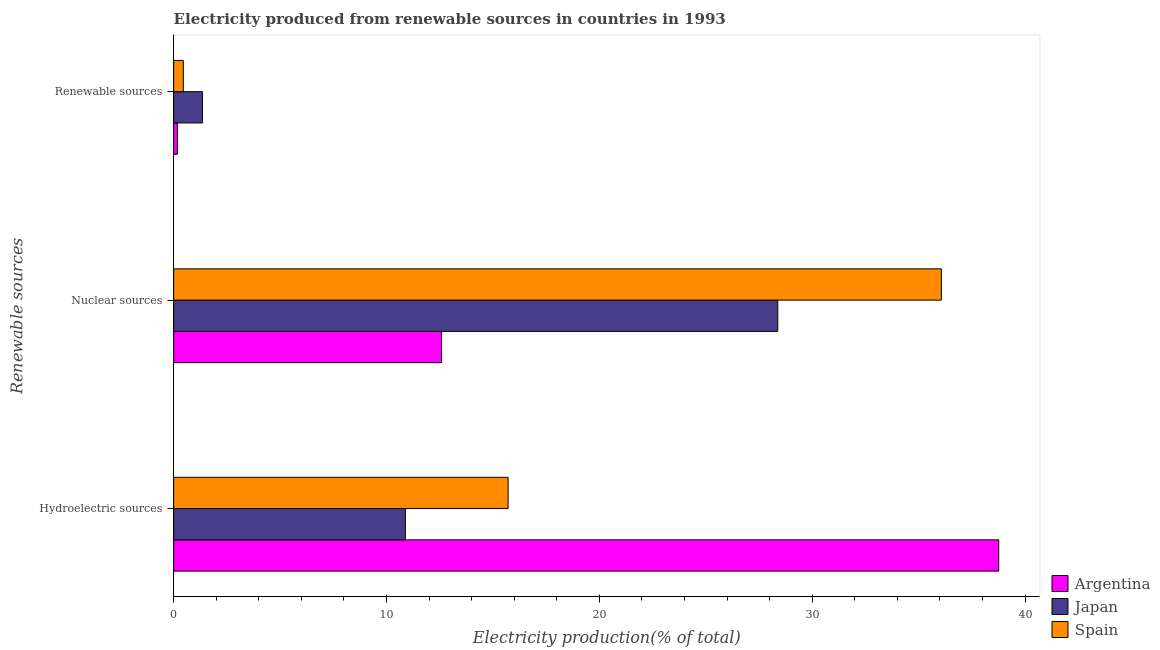How many different coloured bars are there?
Keep it short and to the point. 3. Are the number of bars per tick equal to the number of legend labels?
Offer a terse response. Yes. How many bars are there on the 3rd tick from the bottom?
Ensure brevity in your answer.  3. What is the label of the 3rd group of bars from the top?
Make the answer very short. Hydroelectric sources. What is the percentage of electricity produced by hydroelectric sources in Argentina?
Offer a terse response. 38.76. Across all countries, what is the maximum percentage of electricity produced by nuclear sources?
Your answer should be compact. 36.07. Across all countries, what is the minimum percentage of electricity produced by nuclear sources?
Keep it short and to the point. 12.59. In which country was the percentage of electricity produced by renewable sources minimum?
Provide a succinct answer. Argentina. What is the total percentage of electricity produced by nuclear sources in the graph?
Provide a succinct answer. 77.03. What is the difference between the percentage of electricity produced by hydroelectric sources in Japan and that in Argentina?
Provide a succinct answer. -27.88. What is the difference between the percentage of electricity produced by renewable sources in Argentina and the percentage of electricity produced by nuclear sources in Japan?
Make the answer very short. -28.21. What is the average percentage of electricity produced by hydroelectric sources per country?
Keep it short and to the point. 21.78. What is the difference between the percentage of electricity produced by renewable sources and percentage of electricity produced by hydroelectric sources in Spain?
Keep it short and to the point. -15.26. What is the ratio of the percentage of electricity produced by nuclear sources in Spain to that in Argentina?
Ensure brevity in your answer.  2.87. What is the difference between the highest and the second highest percentage of electricity produced by nuclear sources?
Keep it short and to the point. 7.69. What is the difference between the highest and the lowest percentage of electricity produced by hydroelectric sources?
Give a very brief answer. 27.88. Is the sum of the percentage of electricity produced by hydroelectric sources in Argentina and Spain greater than the maximum percentage of electricity produced by nuclear sources across all countries?
Keep it short and to the point. Yes. Is it the case that in every country, the sum of the percentage of electricity produced by hydroelectric sources and percentage of electricity produced by nuclear sources is greater than the percentage of electricity produced by renewable sources?
Offer a very short reply. Yes. Are the values on the major ticks of X-axis written in scientific E-notation?
Provide a succinct answer. No. What is the title of the graph?
Give a very brief answer. Electricity produced from renewable sources in countries in 1993. Does "Turkmenistan" appear as one of the legend labels in the graph?
Give a very brief answer. No. What is the label or title of the Y-axis?
Your answer should be compact. Renewable sources. What is the Electricity production(% of total) of Argentina in Hydroelectric sources?
Offer a very short reply. 38.76. What is the Electricity production(% of total) in Japan in Hydroelectric sources?
Your response must be concise. 10.88. What is the Electricity production(% of total) of Spain in Hydroelectric sources?
Ensure brevity in your answer.  15.71. What is the Electricity production(% of total) in Argentina in Nuclear sources?
Provide a succinct answer. 12.59. What is the Electricity production(% of total) in Japan in Nuclear sources?
Your answer should be very brief. 28.38. What is the Electricity production(% of total) in Spain in Nuclear sources?
Ensure brevity in your answer.  36.07. What is the Electricity production(% of total) of Argentina in Renewable sources?
Offer a terse response. 0.17. What is the Electricity production(% of total) of Japan in Renewable sources?
Keep it short and to the point. 1.35. What is the Electricity production(% of total) in Spain in Renewable sources?
Offer a terse response. 0.45. Across all Renewable sources, what is the maximum Electricity production(% of total) in Argentina?
Make the answer very short. 38.76. Across all Renewable sources, what is the maximum Electricity production(% of total) in Japan?
Keep it short and to the point. 28.38. Across all Renewable sources, what is the maximum Electricity production(% of total) of Spain?
Give a very brief answer. 36.07. Across all Renewable sources, what is the minimum Electricity production(% of total) of Argentina?
Give a very brief answer. 0.17. Across all Renewable sources, what is the minimum Electricity production(% of total) of Japan?
Offer a very short reply. 1.35. Across all Renewable sources, what is the minimum Electricity production(% of total) of Spain?
Offer a terse response. 0.45. What is the total Electricity production(% of total) in Argentina in the graph?
Keep it short and to the point. 51.52. What is the total Electricity production(% of total) in Japan in the graph?
Offer a terse response. 40.62. What is the total Electricity production(% of total) in Spain in the graph?
Make the answer very short. 52.23. What is the difference between the Electricity production(% of total) of Argentina in Hydroelectric sources and that in Nuclear sources?
Ensure brevity in your answer.  26.17. What is the difference between the Electricity production(% of total) of Japan in Hydroelectric sources and that in Nuclear sources?
Give a very brief answer. -17.5. What is the difference between the Electricity production(% of total) of Spain in Hydroelectric sources and that in Nuclear sources?
Offer a very short reply. -20.36. What is the difference between the Electricity production(% of total) in Argentina in Hydroelectric sources and that in Renewable sources?
Keep it short and to the point. 38.59. What is the difference between the Electricity production(% of total) of Japan in Hydroelectric sources and that in Renewable sources?
Offer a very short reply. 9.53. What is the difference between the Electricity production(% of total) of Spain in Hydroelectric sources and that in Renewable sources?
Keep it short and to the point. 15.26. What is the difference between the Electricity production(% of total) in Argentina in Nuclear sources and that in Renewable sources?
Offer a terse response. 12.41. What is the difference between the Electricity production(% of total) in Japan in Nuclear sources and that in Renewable sources?
Ensure brevity in your answer.  27.03. What is the difference between the Electricity production(% of total) of Spain in Nuclear sources and that in Renewable sources?
Offer a terse response. 35.61. What is the difference between the Electricity production(% of total) in Argentina in Hydroelectric sources and the Electricity production(% of total) in Japan in Nuclear sources?
Offer a terse response. 10.38. What is the difference between the Electricity production(% of total) in Argentina in Hydroelectric sources and the Electricity production(% of total) in Spain in Nuclear sources?
Make the answer very short. 2.69. What is the difference between the Electricity production(% of total) of Japan in Hydroelectric sources and the Electricity production(% of total) of Spain in Nuclear sources?
Your response must be concise. -25.18. What is the difference between the Electricity production(% of total) of Argentina in Hydroelectric sources and the Electricity production(% of total) of Japan in Renewable sources?
Your response must be concise. 37.41. What is the difference between the Electricity production(% of total) in Argentina in Hydroelectric sources and the Electricity production(% of total) in Spain in Renewable sources?
Provide a succinct answer. 38.31. What is the difference between the Electricity production(% of total) in Japan in Hydroelectric sources and the Electricity production(% of total) in Spain in Renewable sources?
Your response must be concise. 10.43. What is the difference between the Electricity production(% of total) in Argentina in Nuclear sources and the Electricity production(% of total) in Japan in Renewable sources?
Offer a terse response. 11.23. What is the difference between the Electricity production(% of total) in Argentina in Nuclear sources and the Electricity production(% of total) in Spain in Renewable sources?
Your response must be concise. 12.13. What is the difference between the Electricity production(% of total) of Japan in Nuclear sources and the Electricity production(% of total) of Spain in Renewable sources?
Your response must be concise. 27.93. What is the average Electricity production(% of total) in Argentina per Renewable sources?
Keep it short and to the point. 17.17. What is the average Electricity production(% of total) in Japan per Renewable sources?
Offer a very short reply. 13.54. What is the average Electricity production(% of total) in Spain per Renewable sources?
Keep it short and to the point. 17.41. What is the difference between the Electricity production(% of total) of Argentina and Electricity production(% of total) of Japan in Hydroelectric sources?
Give a very brief answer. 27.88. What is the difference between the Electricity production(% of total) of Argentina and Electricity production(% of total) of Spain in Hydroelectric sources?
Offer a terse response. 23.05. What is the difference between the Electricity production(% of total) in Japan and Electricity production(% of total) in Spain in Hydroelectric sources?
Make the answer very short. -4.83. What is the difference between the Electricity production(% of total) in Argentina and Electricity production(% of total) in Japan in Nuclear sources?
Make the answer very short. -15.79. What is the difference between the Electricity production(% of total) in Argentina and Electricity production(% of total) in Spain in Nuclear sources?
Provide a short and direct response. -23.48. What is the difference between the Electricity production(% of total) of Japan and Electricity production(% of total) of Spain in Nuclear sources?
Your answer should be very brief. -7.69. What is the difference between the Electricity production(% of total) of Argentina and Electricity production(% of total) of Japan in Renewable sources?
Provide a succinct answer. -1.18. What is the difference between the Electricity production(% of total) of Argentina and Electricity production(% of total) of Spain in Renewable sources?
Offer a terse response. -0.28. What is the difference between the Electricity production(% of total) of Japan and Electricity production(% of total) of Spain in Renewable sources?
Provide a succinct answer. 0.9. What is the ratio of the Electricity production(% of total) of Argentina in Hydroelectric sources to that in Nuclear sources?
Give a very brief answer. 3.08. What is the ratio of the Electricity production(% of total) in Japan in Hydroelectric sources to that in Nuclear sources?
Your response must be concise. 0.38. What is the ratio of the Electricity production(% of total) of Spain in Hydroelectric sources to that in Nuclear sources?
Offer a very short reply. 0.44. What is the ratio of the Electricity production(% of total) in Argentina in Hydroelectric sources to that in Renewable sources?
Offer a very short reply. 223.06. What is the ratio of the Electricity production(% of total) in Japan in Hydroelectric sources to that in Renewable sources?
Make the answer very short. 8.04. What is the ratio of the Electricity production(% of total) of Spain in Hydroelectric sources to that in Renewable sources?
Your response must be concise. 34.69. What is the ratio of the Electricity production(% of total) of Argentina in Nuclear sources to that in Renewable sources?
Keep it short and to the point. 72.43. What is the ratio of the Electricity production(% of total) in Japan in Nuclear sources to that in Renewable sources?
Give a very brief answer. 20.95. What is the ratio of the Electricity production(% of total) of Spain in Nuclear sources to that in Renewable sources?
Make the answer very short. 79.63. What is the difference between the highest and the second highest Electricity production(% of total) of Argentina?
Make the answer very short. 26.17. What is the difference between the highest and the second highest Electricity production(% of total) of Japan?
Ensure brevity in your answer.  17.5. What is the difference between the highest and the second highest Electricity production(% of total) of Spain?
Offer a terse response. 20.36. What is the difference between the highest and the lowest Electricity production(% of total) of Argentina?
Offer a terse response. 38.59. What is the difference between the highest and the lowest Electricity production(% of total) in Japan?
Your response must be concise. 27.03. What is the difference between the highest and the lowest Electricity production(% of total) in Spain?
Give a very brief answer. 35.61. 